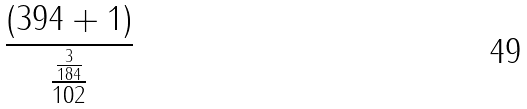Convert formula to latex. <formula><loc_0><loc_0><loc_500><loc_500>\frac { ( 3 9 4 + 1 ) } { \frac { \frac { 3 } { 1 8 4 } } { 1 0 2 } }</formula> 